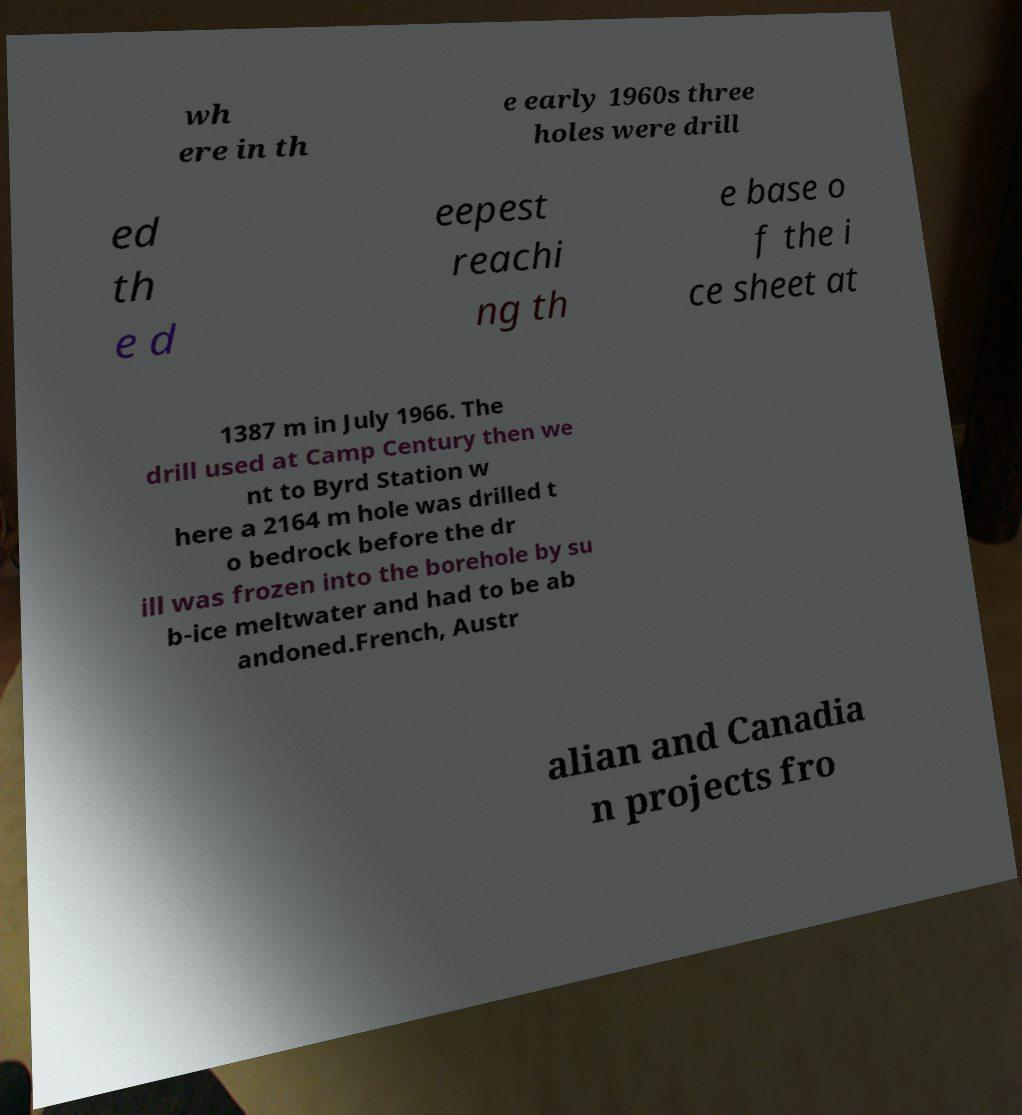Please identify and transcribe the text found in this image. wh ere in th e early 1960s three holes were drill ed th e d eepest reachi ng th e base o f the i ce sheet at 1387 m in July 1966. The drill used at Camp Century then we nt to Byrd Station w here a 2164 m hole was drilled t o bedrock before the dr ill was frozen into the borehole by su b-ice meltwater and had to be ab andoned.French, Austr alian and Canadia n projects fro 